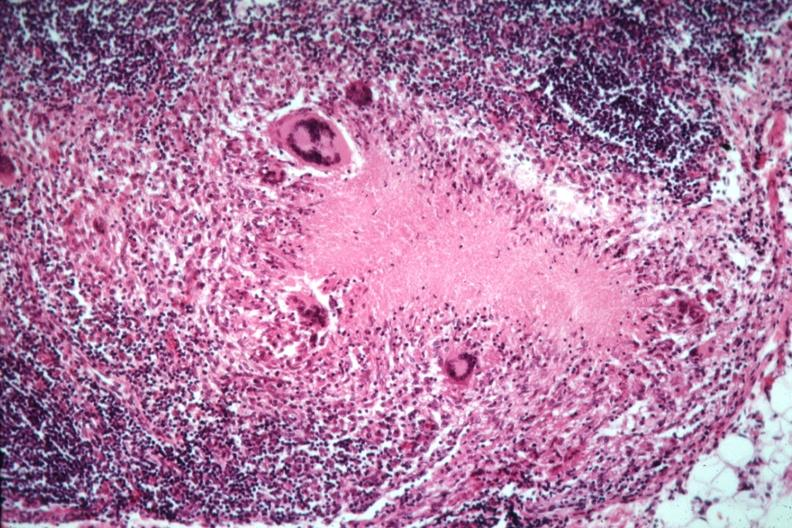what does this image show?
Answer the question using a single word or phrase. Good example necrotizing granuloma with giant cells 